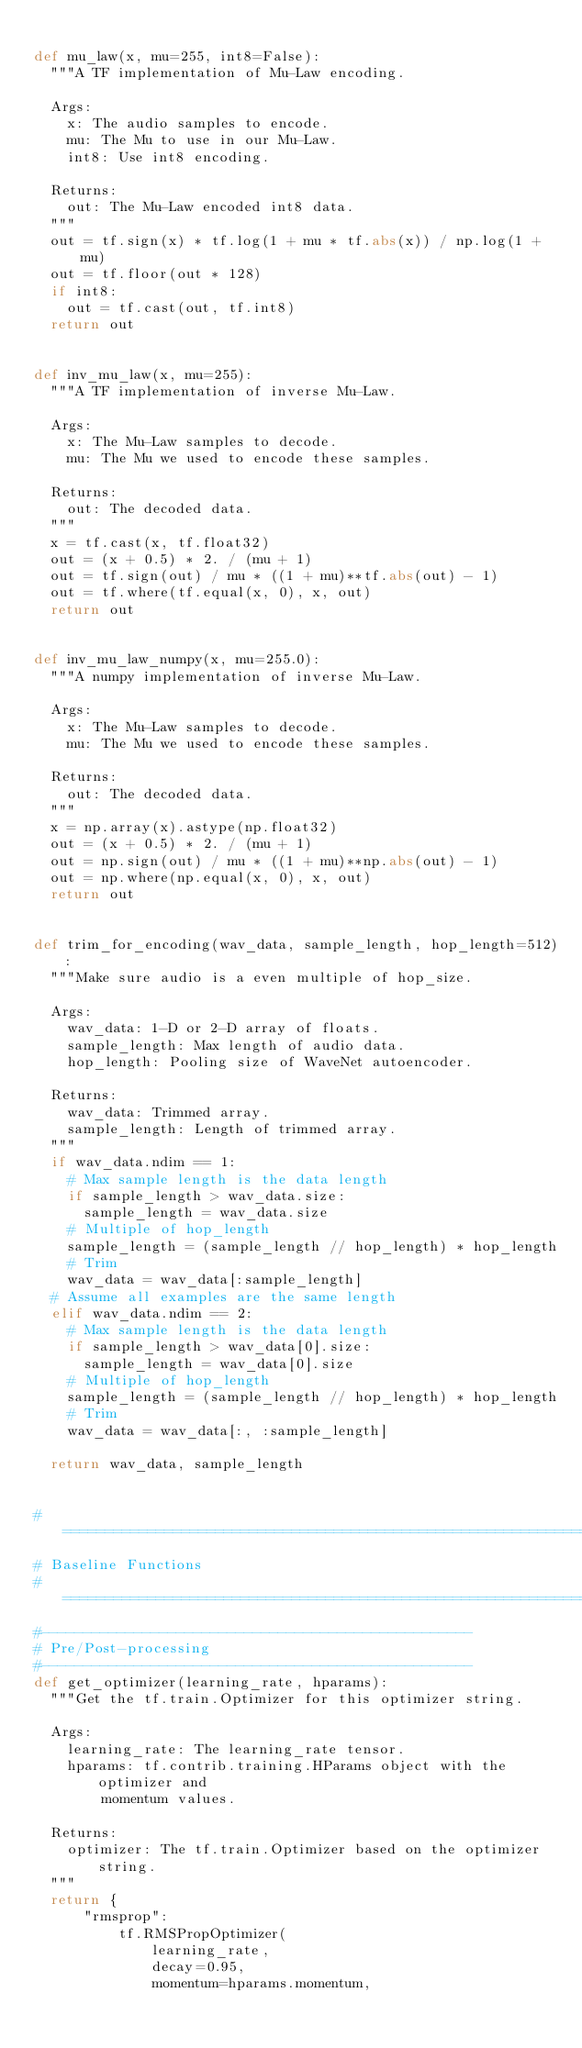Convert code to text. <code><loc_0><loc_0><loc_500><loc_500><_Python_>
def mu_law(x, mu=255, int8=False):
  """A TF implementation of Mu-Law encoding.

  Args:
    x: The audio samples to encode.
    mu: The Mu to use in our Mu-Law.
    int8: Use int8 encoding.

  Returns:
    out: The Mu-Law encoded int8 data.
  """
  out = tf.sign(x) * tf.log(1 + mu * tf.abs(x)) / np.log(1 + mu)
  out = tf.floor(out * 128)
  if int8:
    out = tf.cast(out, tf.int8)
  return out


def inv_mu_law(x, mu=255):
  """A TF implementation of inverse Mu-Law.

  Args:
    x: The Mu-Law samples to decode.
    mu: The Mu we used to encode these samples.

  Returns:
    out: The decoded data.
  """
  x = tf.cast(x, tf.float32)
  out = (x + 0.5) * 2. / (mu + 1)
  out = tf.sign(out) / mu * ((1 + mu)**tf.abs(out) - 1)
  out = tf.where(tf.equal(x, 0), x, out)
  return out


def inv_mu_law_numpy(x, mu=255.0):
  """A numpy implementation of inverse Mu-Law.

  Args:
    x: The Mu-Law samples to decode.
    mu: The Mu we used to encode these samples.

  Returns:
    out: The decoded data.
  """
  x = np.array(x).astype(np.float32)
  out = (x + 0.5) * 2. / (mu + 1)
  out = np.sign(out) / mu * ((1 + mu)**np.abs(out) - 1)
  out = np.where(np.equal(x, 0), x, out)
  return out


def trim_for_encoding(wav_data, sample_length, hop_length=512):
  """Make sure audio is a even multiple of hop_size.

  Args:
    wav_data: 1-D or 2-D array of floats.
    sample_length: Max length of audio data.
    hop_length: Pooling size of WaveNet autoencoder.

  Returns:
    wav_data: Trimmed array.
    sample_length: Length of trimmed array.
  """
  if wav_data.ndim == 1:
    # Max sample length is the data length
    if sample_length > wav_data.size:
      sample_length = wav_data.size
    # Multiple of hop_length
    sample_length = (sample_length // hop_length) * hop_length
    # Trim
    wav_data = wav_data[:sample_length]
  # Assume all examples are the same length
  elif wav_data.ndim == 2:
    # Max sample length is the data length
    if sample_length > wav_data[0].size:
      sample_length = wav_data[0].size
    # Multiple of hop_length
    sample_length = (sample_length // hop_length) * hop_length
    # Trim
    wav_data = wav_data[:, :sample_length]

  return wav_data, sample_length


#===============================================================================
# Baseline Functions
#===============================================================================
#---------------------------------------------------
# Pre/Post-processing
#---------------------------------------------------
def get_optimizer(learning_rate, hparams):
  """Get the tf.train.Optimizer for this optimizer string.

  Args:
    learning_rate: The learning_rate tensor.
    hparams: tf.contrib.training.HParams object with the optimizer and
        momentum values.

  Returns:
    optimizer: The tf.train.Optimizer based on the optimizer string.
  """
  return {
      "rmsprop":
          tf.RMSPropOptimizer(
              learning_rate,
              decay=0.95,
              momentum=hparams.momentum,</code> 